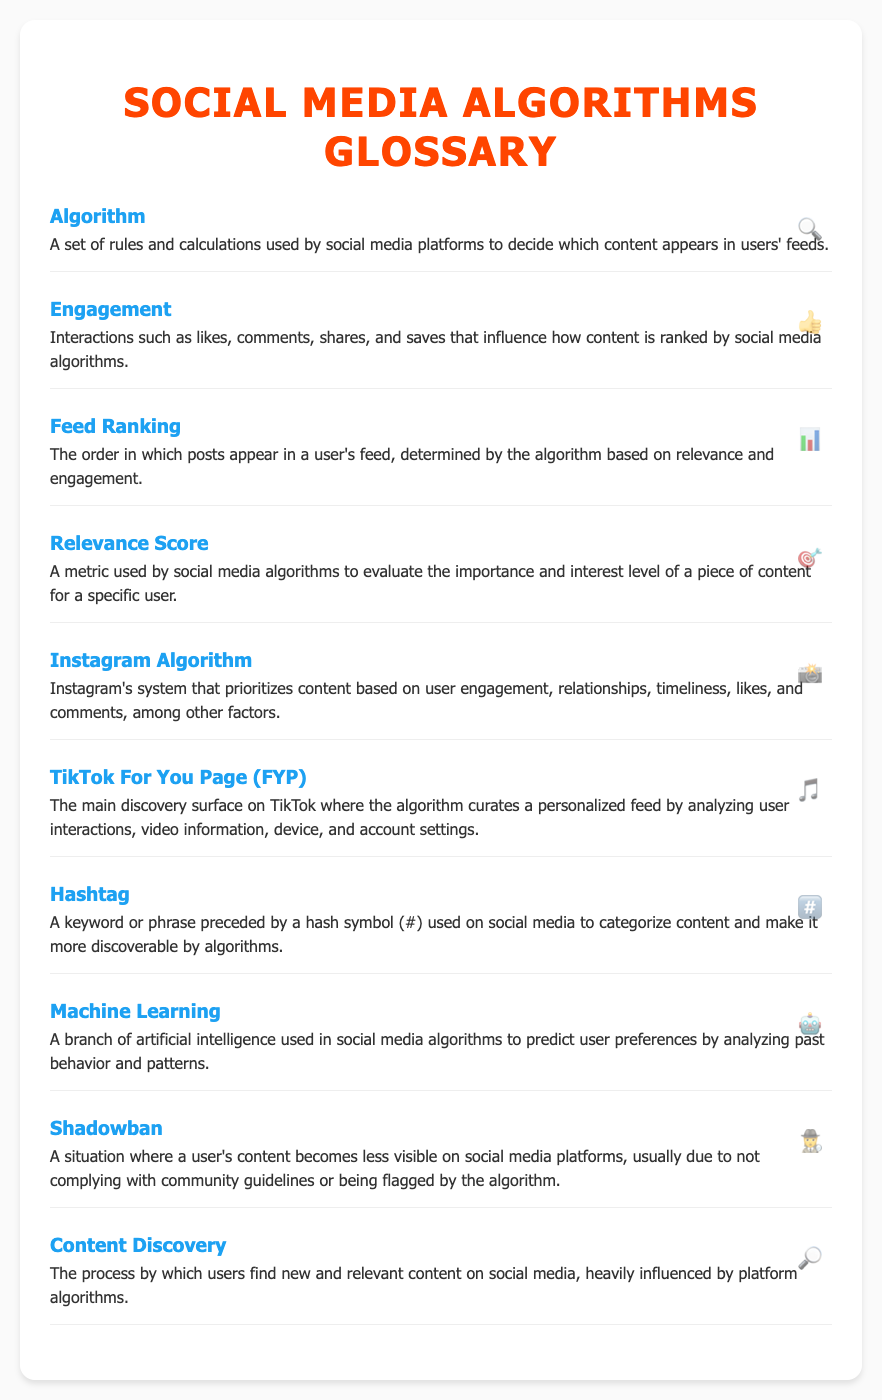what is an algorithm? An algorithm is a set of rules and calculations used by social media platforms to decide which content appears in users' feeds.
Answer: A set of rules and calculations what does engagement refer to? Engagement refers to interactions such as likes, comments, shares, and saves that influence how content is ranked by social media algorithms.
Answer: Interactions such as likes, comments, shares, and saves what is the main function of feed ranking? Feed ranking determines the order in which posts appear in a user's feed, based on relevance and engagement.
Answer: Determines the order of posts what is a relevance score? A relevance score is a metric used by social media algorithms to evaluate the importance and interest level of a piece of content for a specific user.
Answer: A metric used to evaluate importance and interest what factors influence the Instagram algorithm? The Instagram algorithm prioritizes content based on user engagement, relationships, timeliness, likes, and comments, among other factors.
Answer: User engagement, relationships, timeliness, likes, comments what is the TikTok For You Page (FYP)? The TikTok For You Page is the main discovery surface on TikTok where the algorithm curates a personalized feed by analyzing user interactions.
Answer: The main discovery surface on TikTok what is a hashtag? A hashtag is a keyword or phrase preceded by a hash symbol (#) used on social media to categorize content.
Answer: A keyword or phrase preceded by a hash symbol what is the purpose of content discovery? The purpose of content discovery is the process by which users find new and relevant content on social media, influenced by platform algorithms.
Answer: To find new and relevant content how does machine learning relate to social media? Machine learning is used in social media algorithms to predict user preferences by analyzing past behavior and patterns.
Answer: Predict user preferences by analyzing behavior what is a shadowban? A shadowban is a situation where a user's content becomes less visible on social media platforms, usually due to not complying with community guidelines.
Answer: Less visible content due to violations 